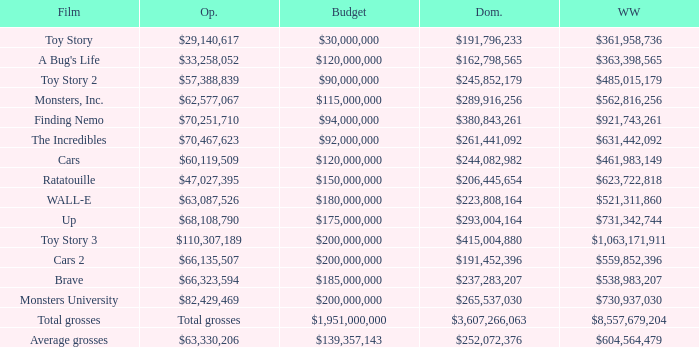WHAT IS THE OPENING WITH A WORLDWIDE NUMBER OF $559,852,396? $66,135,507. Parse the table in full. {'header': ['Film', 'Op.', 'Budget', 'Dom.', 'WW'], 'rows': [['Toy Story', '$29,140,617', '$30,000,000', '$191,796,233', '$361,958,736'], ["A Bug's Life", '$33,258,052', '$120,000,000', '$162,798,565', '$363,398,565'], ['Toy Story 2', '$57,388,839', '$90,000,000', '$245,852,179', '$485,015,179'], ['Monsters, Inc.', '$62,577,067', '$115,000,000', '$289,916,256', '$562,816,256'], ['Finding Nemo', '$70,251,710', '$94,000,000', '$380,843,261', '$921,743,261'], ['The Incredibles', '$70,467,623', '$92,000,000', '$261,441,092', '$631,442,092'], ['Cars', '$60,119,509', '$120,000,000', '$244,082,982', '$461,983,149'], ['Ratatouille', '$47,027,395', '$150,000,000', '$206,445,654', '$623,722,818'], ['WALL-E', '$63,087,526', '$180,000,000', '$223,808,164', '$521,311,860'], ['Up', '$68,108,790', '$175,000,000', '$293,004,164', '$731,342,744'], ['Toy Story 3', '$110,307,189', '$200,000,000', '$415,004,880', '$1,063,171,911'], ['Cars 2', '$66,135,507', '$200,000,000', '$191,452,396', '$559,852,396'], ['Brave', '$66,323,594', '$185,000,000', '$237,283,207', '$538,983,207'], ['Monsters University', '$82,429,469', '$200,000,000', '$265,537,030', '$730,937,030'], ['Total grosses', 'Total grosses', '$1,951,000,000', '$3,607,266,063', '$8,557,679,204'], ['Average grosses', '$63,330,206', '$139,357,143', '$252,072,376', '$604,564,479']]} 